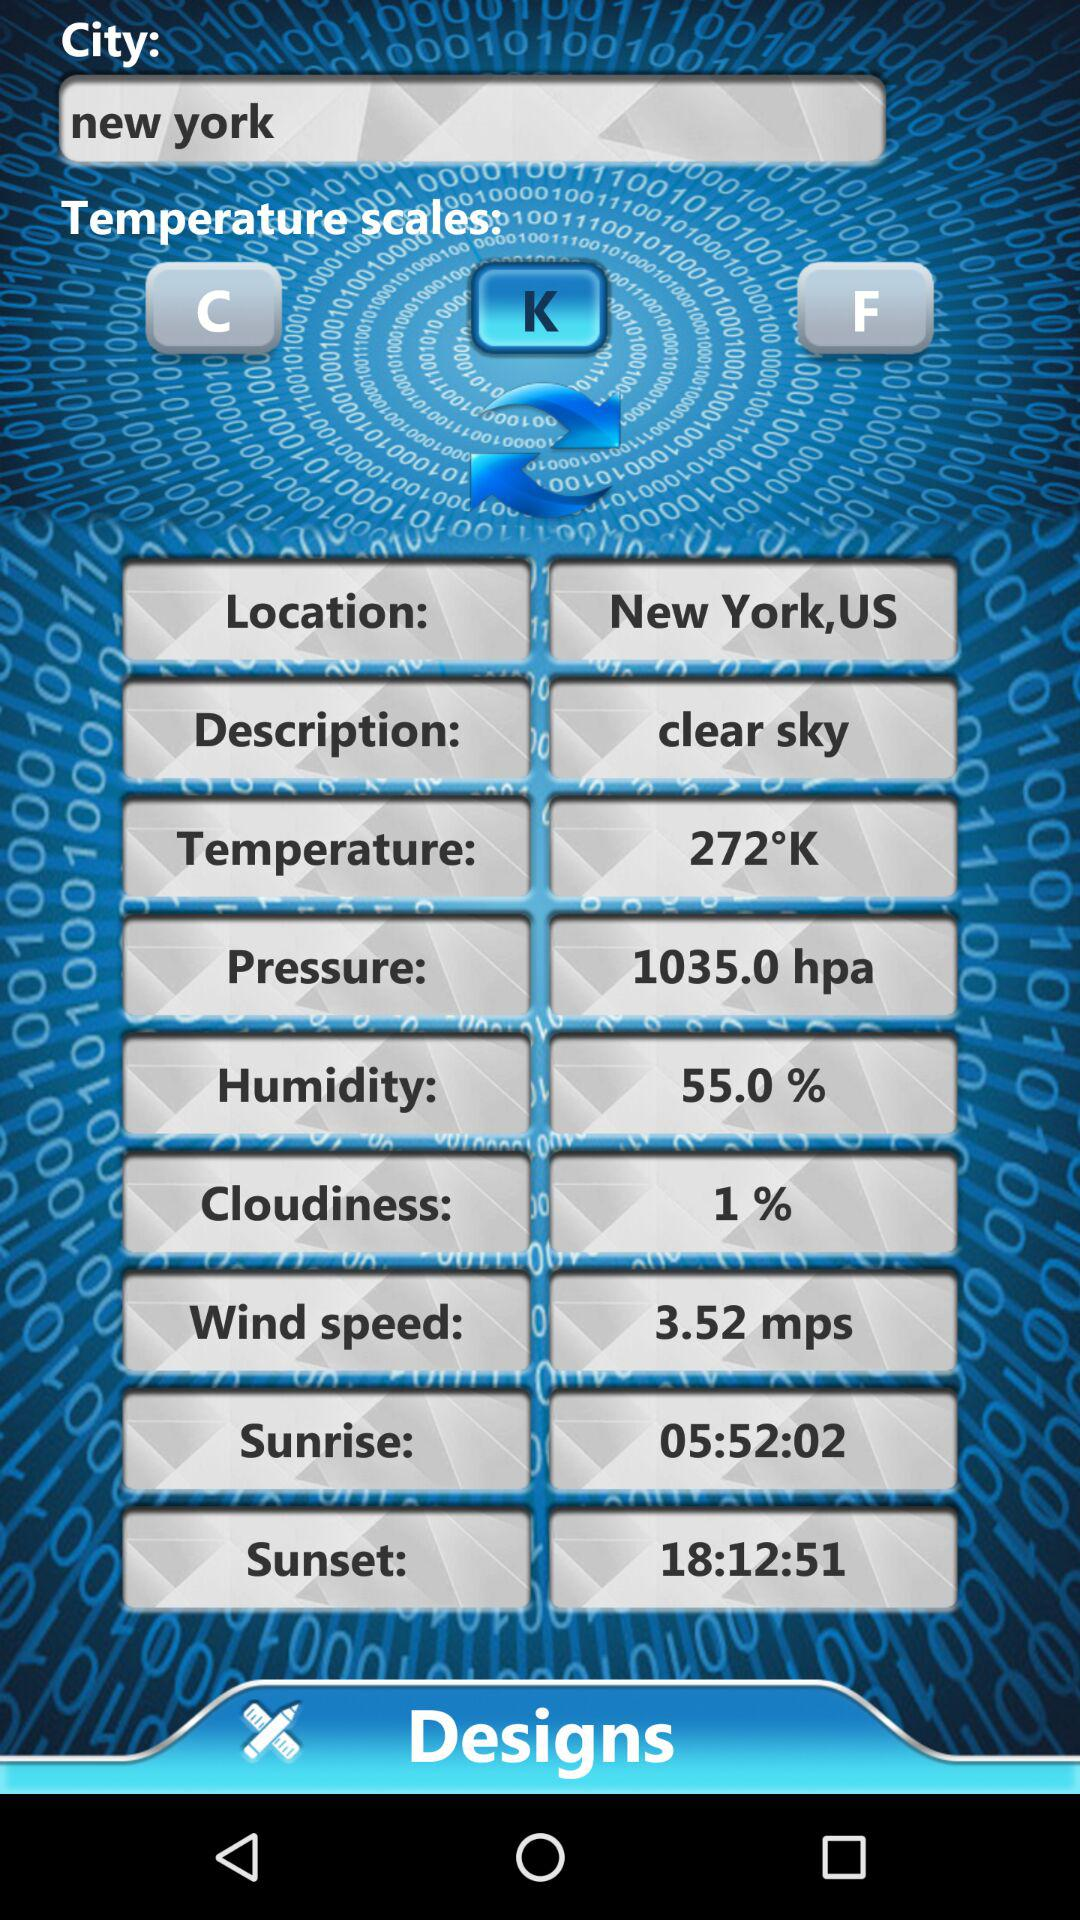What is the selected temperature scale? The selected temperature scale is "Kelvin". 